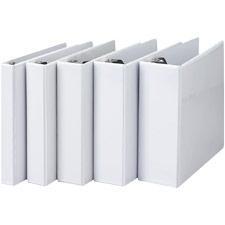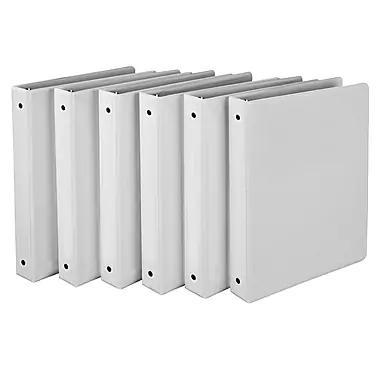The first image is the image on the left, the second image is the image on the right. Considering the images on both sides, is "All binders shown are white and all binders are displayed upright." valid? Answer yes or no. Yes. The first image is the image on the left, the second image is the image on the right. Considering the images on both sides, is "All binders are the base color white and there are at least five present." valid? Answer yes or no. Yes. 